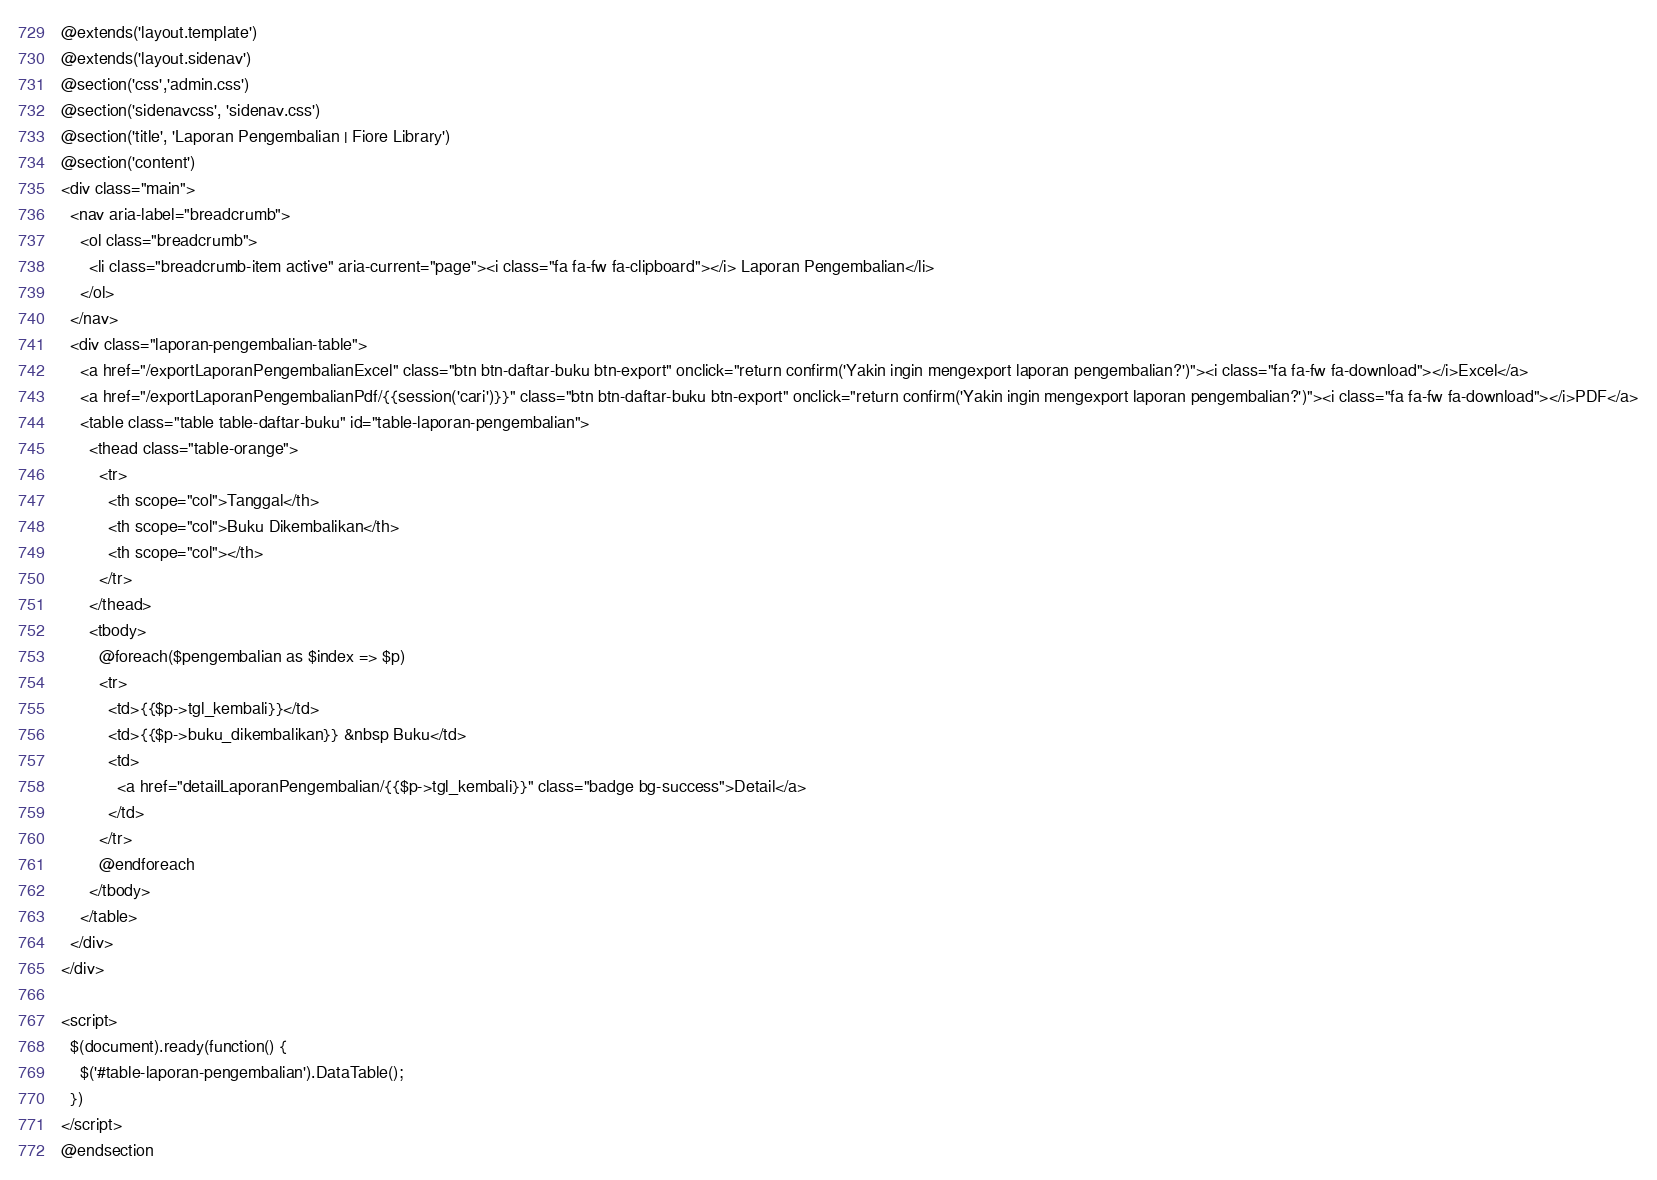<code> <loc_0><loc_0><loc_500><loc_500><_PHP_>@extends('layout.template')
@extends('layout.sidenav')
@section('css','admin.css')
@section('sidenavcss', 'sidenav.css')
@section('title', 'Laporan Pengembalian | Fiore Library')
@section('content')
<div class="main">
  <nav aria-label="breadcrumb">
    <ol class="breadcrumb">
      <li class="breadcrumb-item active" aria-current="page"><i class="fa fa-fw fa-clipboard"></i> Laporan Pengembalian</li>
    </ol>
  </nav>
  <div class="laporan-pengembalian-table">
    <a href="/exportLaporanPengembalianExcel" class="btn btn-daftar-buku btn-export" onclick="return confirm('Yakin ingin mengexport laporan pengembalian?')"><i class="fa fa-fw fa-download"></i>Excel</a>
    <a href="/exportLaporanPengembalianPdf/{{session('cari')}}" class="btn btn-daftar-buku btn-export" onclick="return confirm('Yakin ingin mengexport laporan pengembalian?')"><i class="fa fa-fw fa-download"></i>PDF</a>
    <table class="table table-daftar-buku" id="table-laporan-pengembalian">
      <thead class="table-orange">
        <tr>
          <th scope="col">Tanggal</th>
          <th scope="col">Buku Dikembalikan</th>
          <th scope="col"></th>
        </tr>
      </thead>
      <tbody>
        @foreach($pengembalian as $index => $p)
        <tr>
          <td>{{$p->tgl_kembali}}</td>
          <td>{{$p->buku_dikembalikan}} &nbsp Buku</td>
          <td>
            <a href="detailLaporanPengembalian/{{$p->tgl_kembali}}" class="badge bg-success">Detail</a>
          </td>
        </tr>
        @endforeach
      </tbody>
    </table>
  </div>
</div>

<script>
  $(document).ready(function() {
    $('#table-laporan-pengembalian').DataTable();
  })
</script>
@endsection</code> 